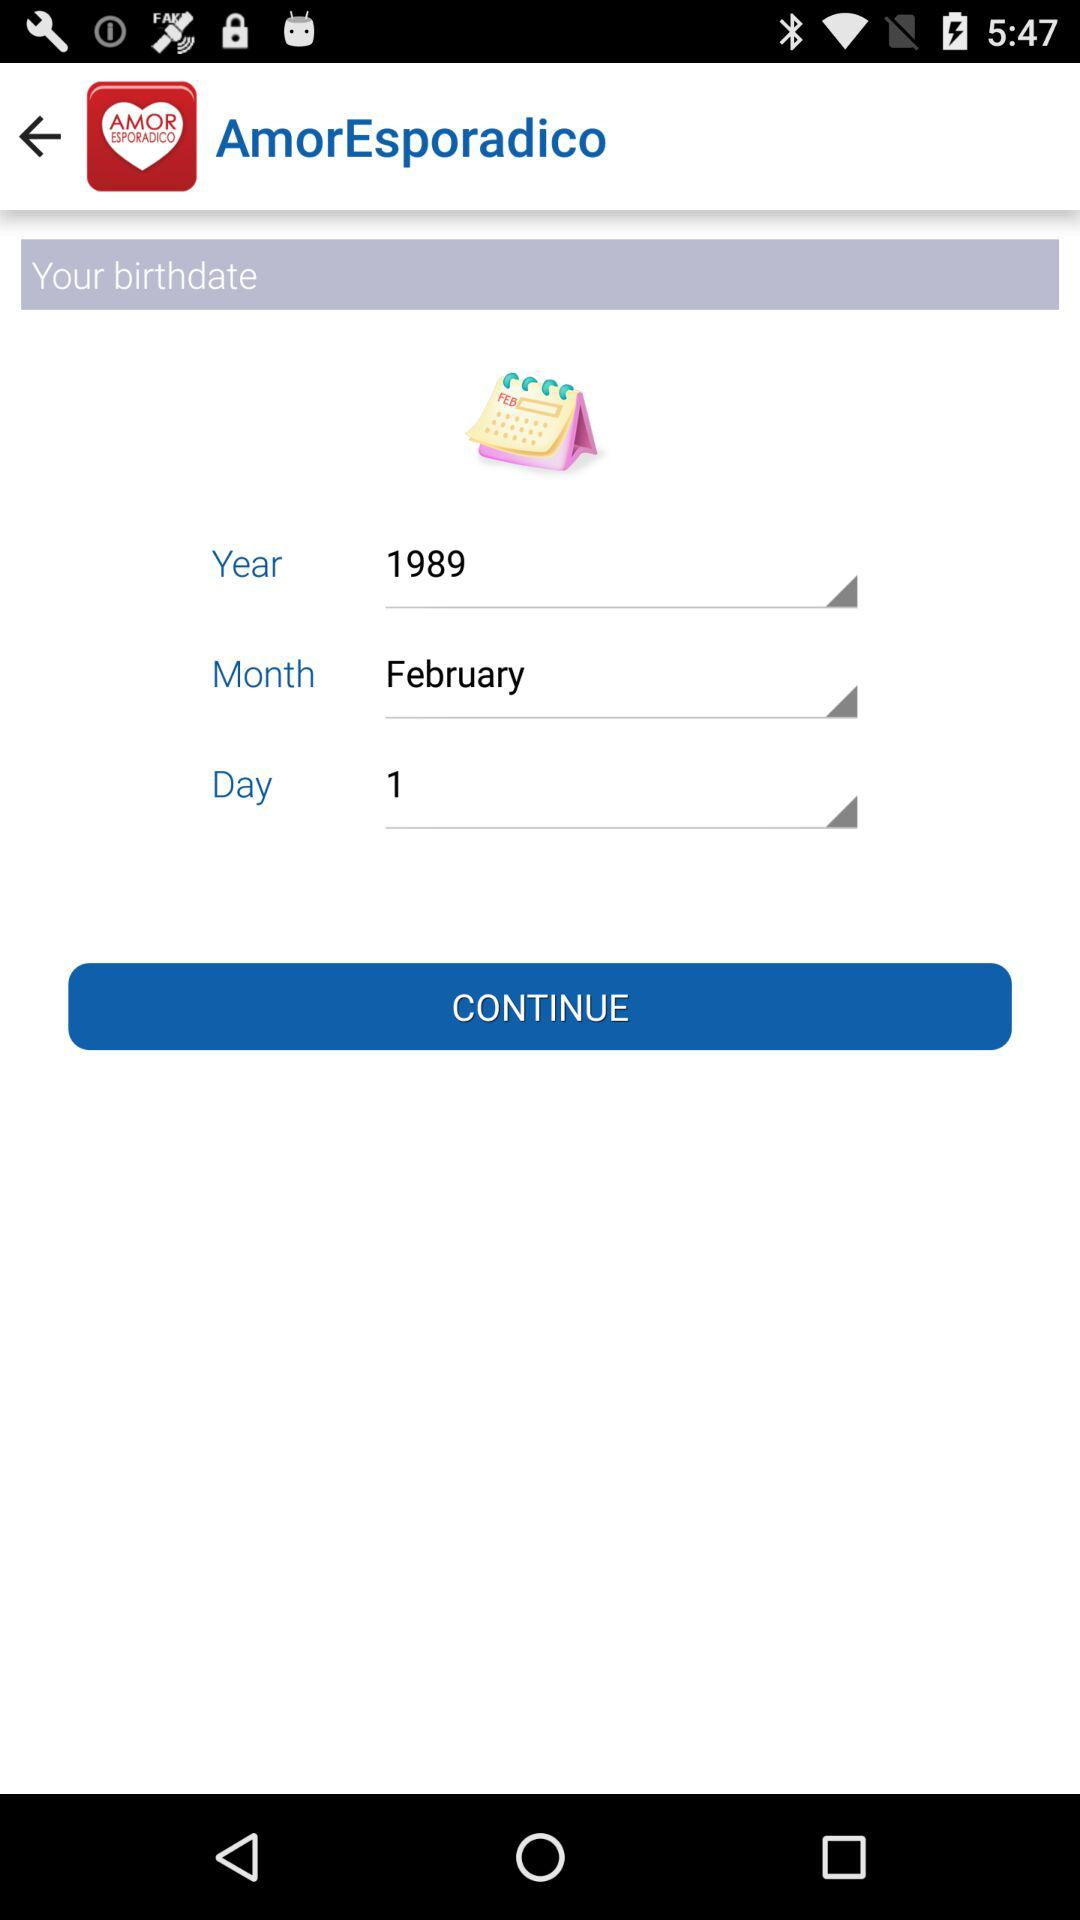What is the date of birth? The date of birth is February 1, 1989. 